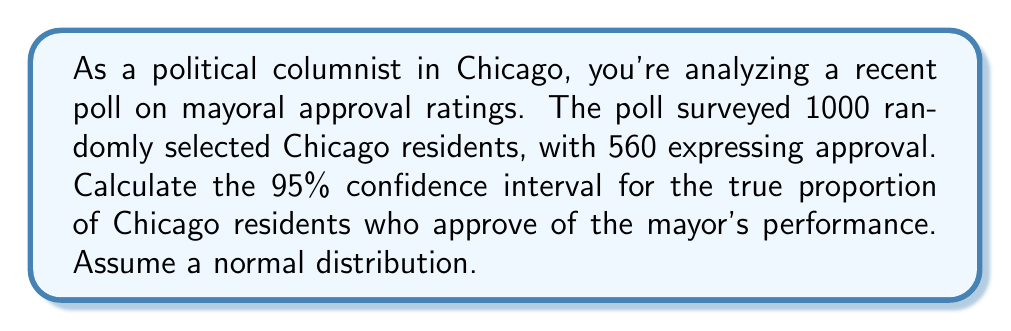Could you help me with this problem? To calculate the confidence interval, we'll follow these steps:

1) First, calculate the sample proportion:
   $\hat{p} = \frac{560}{1000} = 0.56$

2) The standard error for a proportion is given by:
   $SE = \sqrt{\frac{\hat{p}(1-\hat{p})}{n}}$
   
   $SE = \sqrt{\frac{0.56(1-0.56)}{1000}} = \sqrt{\frac{0.2464}{1000}} = 0.0157$

3) For a 95% confidence interval, we use a z-score of 1.96 (from the standard normal distribution).

4) The confidence interval is calculated as:
   $CI = \hat{p} \pm (z \times SE)$
   
   $CI = 0.56 \pm (1.96 \times 0.0157)$
   
   $CI = 0.56 \pm 0.0308$

5) Therefore, the lower bound is:
   $0.56 - 0.0308 = 0.5292$
   
   And the upper bound is:
   $0.56 + 0.0308 = 0.5908$

6) We can express this as a percentage:
   $(52.92\%, 59.08\%)$

This means we can be 95% confident that the true proportion of Chicago residents who approve of the mayor's performance is between 52.92% and 59.08%.
Answer: (52.92%, 59.08%) 